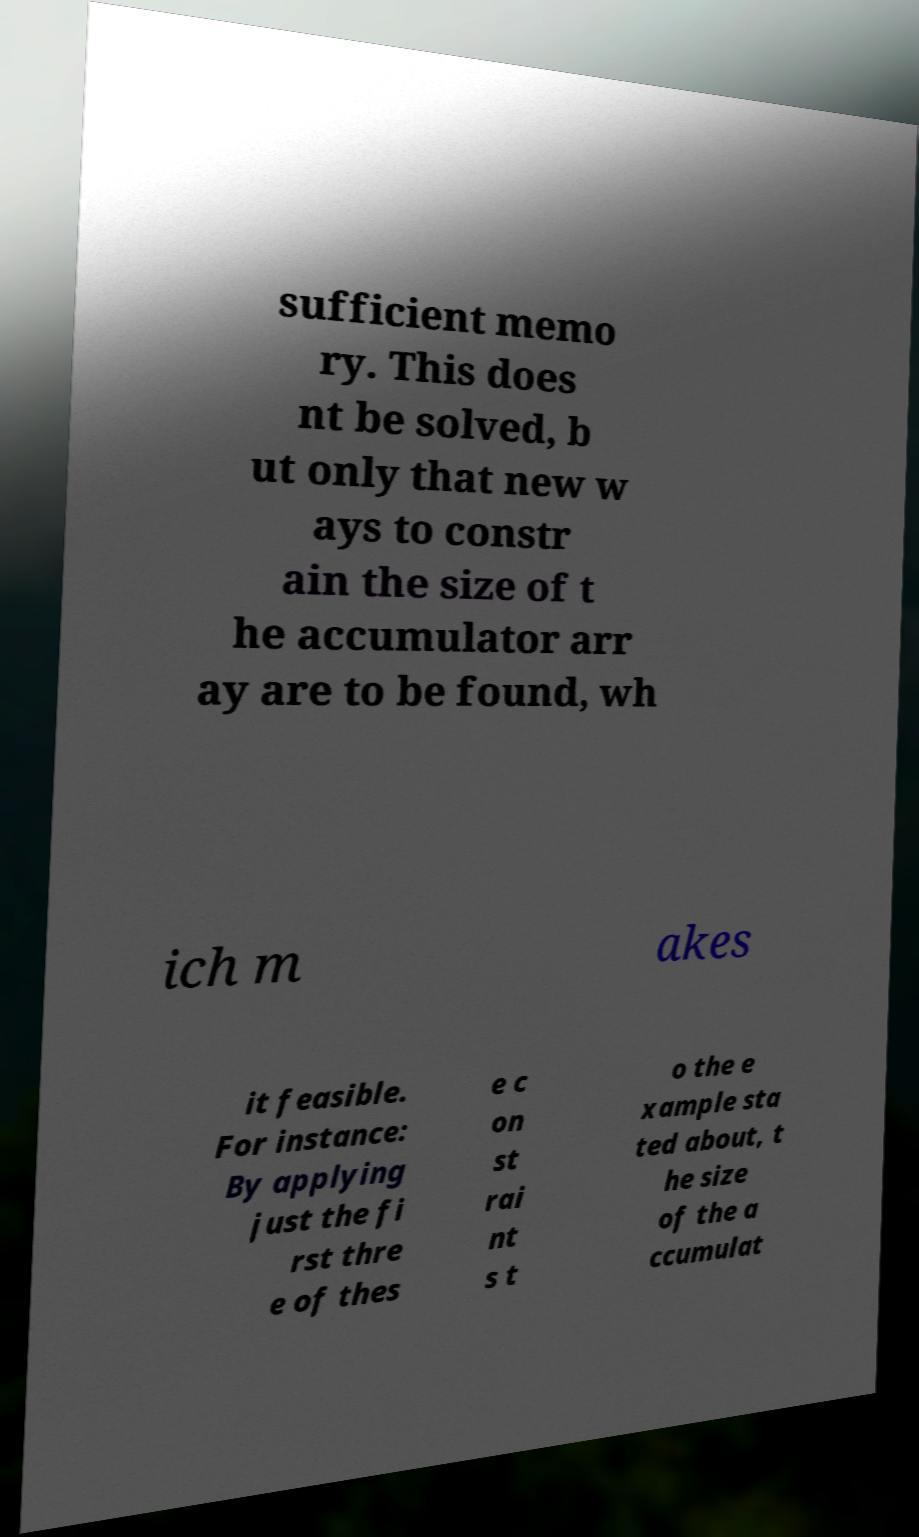There's text embedded in this image that I need extracted. Can you transcribe it verbatim? sufficient memo ry. This does nt be solved, b ut only that new w ays to constr ain the size of t he accumulator arr ay are to be found, wh ich m akes it feasible. For instance: By applying just the fi rst thre e of thes e c on st rai nt s t o the e xample sta ted about, t he size of the a ccumulat 